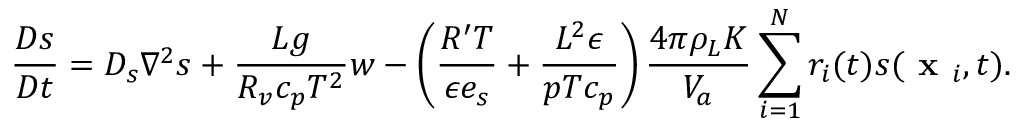Convert formula to latex. <formula><loc_0><loc_0><loc_500><loc_500>\frac { D s } { D t } = D _ { s } \nabla ^ { 2 } s + \frac { L g } { R _ { v } c _ { p } T ^ { 2 } } w - \left ( \frac { R ^ { \prime } T } { \epsilon e _ { s } } + \frac { L ^ { 2 } \epsilon } { p T c _ { p } } \right ) \frac { 4 \pi \rho _ { L } K } { V _ { a } } \sum _ { i = 1 } ^ { N } r _ { i } ( t ) s ( x _ { i } , t ) .</formula> 